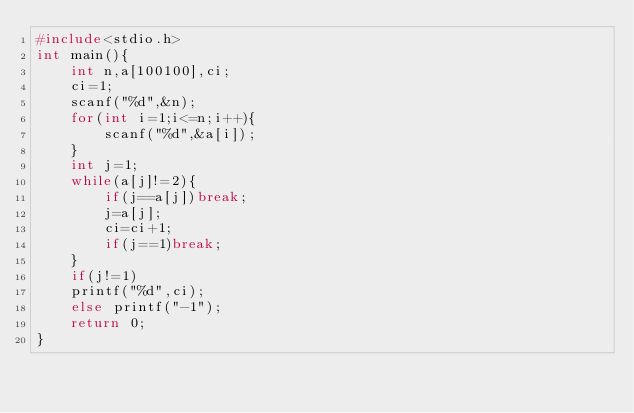<code> <loc_0><loc_0><loc_500><loc_500><_C_>#include<stdio.h>
int main(){
	int n,a[100100],ci;
	ci=1;
	scanf("%d",&n);
	for(int i=1;i<=n;i++){
		scanf("%d",&a[i]);
	}
	int j=1;
	while(a[j]!=2){
		if(j==a[j])break;
		j=a[j];
		ci=ci+1;
		if(j==1)break;
	}
	if(j!=1)
	printf("%d",ci);
	else printf("-1");
	return 0;
}</code> 